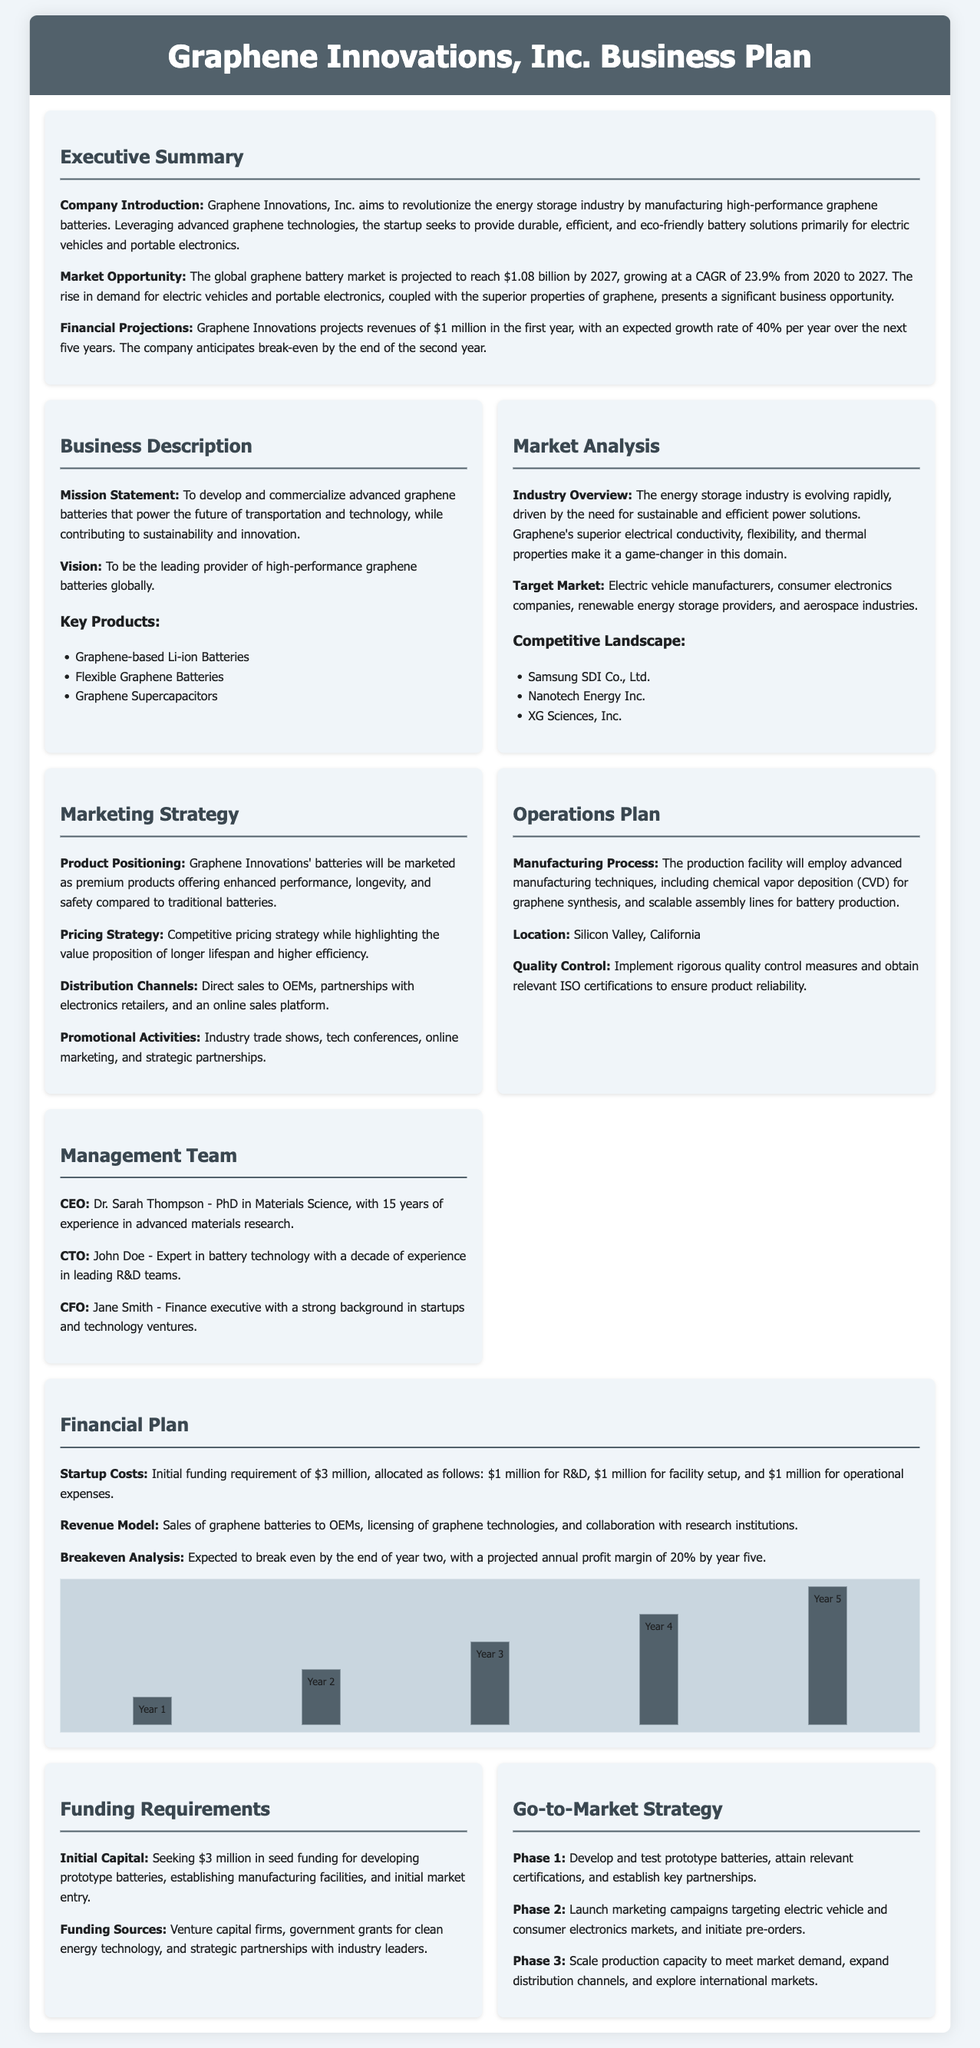what is the company name? The company name is mentioned in the header of the document.
Answer: Graphene Innovations, Inc what is the projected market value by 2027? The document states the projected global graphene battery market value.
Answer: $1.08 billion who is the CEO of the company? The document provides information about the management team and their roles.
Answer: Dr. Sarah Thompson what is the initial funding requirement? This information is outlined in the funding requirements section of the document.
Answer: $3 million what is the expected growth rate for revenues per year? The financial projections section highlights the growth rate for the company's revenues.
Answer: 40% what industry does the startup operate within? The document describes the industry in which the company competes.
Answer: Energy storage what is phase 1 of the go-to-market strategy? This refers to the first step outlined in the go-to-market strategy section of the document.
Answer: Develop and test prototype batteries what is the primary manufacturing location? The operations plan specifies where the company plans to set up its manufacturing.
Answer: Silicon Valley, California what are the key products mentioned? The business description lists the main products offered by the company.
Answer: Graphene-based Li-ion Batteries, Flexible Graphene Batteries, Graphene Supercapacitors 